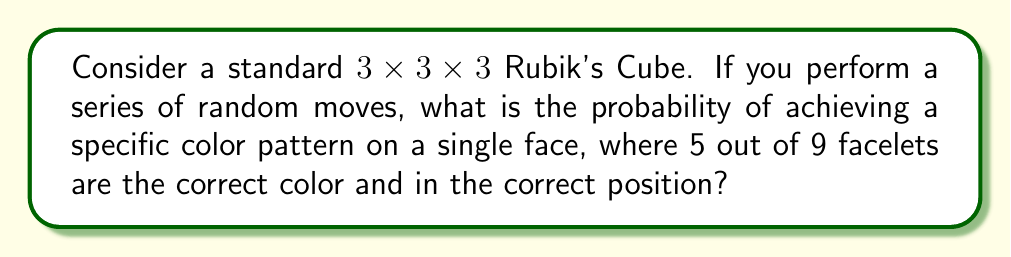Give your solution to this math problem. Let's approach this step-by-step:

1) First, we need to calculate the total number of possible color arrangements on a single face. Each facelet can be one of 6 colors, so the total number of arrangements is:

   $$6^9 = 10,077,696$$

2) Now, we need to calculate the number of arrangements where 5 out of 9 facelets are the correct color and in the correct position.

3) We can use the combination formula to choose which 5 out of 9 facelets will be correct:

   $$\binom{9}{5} = \frac{9!}{5!(9-5)!} = 126$$

4) For the remaining 4 facelets, we need to arrange the other 5 colors (excluding the correct color). This can be done in:

   $$5^4 = 625$$ ways

5) Therefore, the total number of favorable arrangements is:

   $$126 \times 625 = 78,750$$

6) The probability is then the number of favorable outcomes divided by the total number of possible outcomes:

   $$P = \frac{78,750}{10,077,696} = \frac{15,750}{2,015,539} \approx 0.007814$$
Answer: $\frac{15,750}{2,015,539}$ or approximately 0.007814 